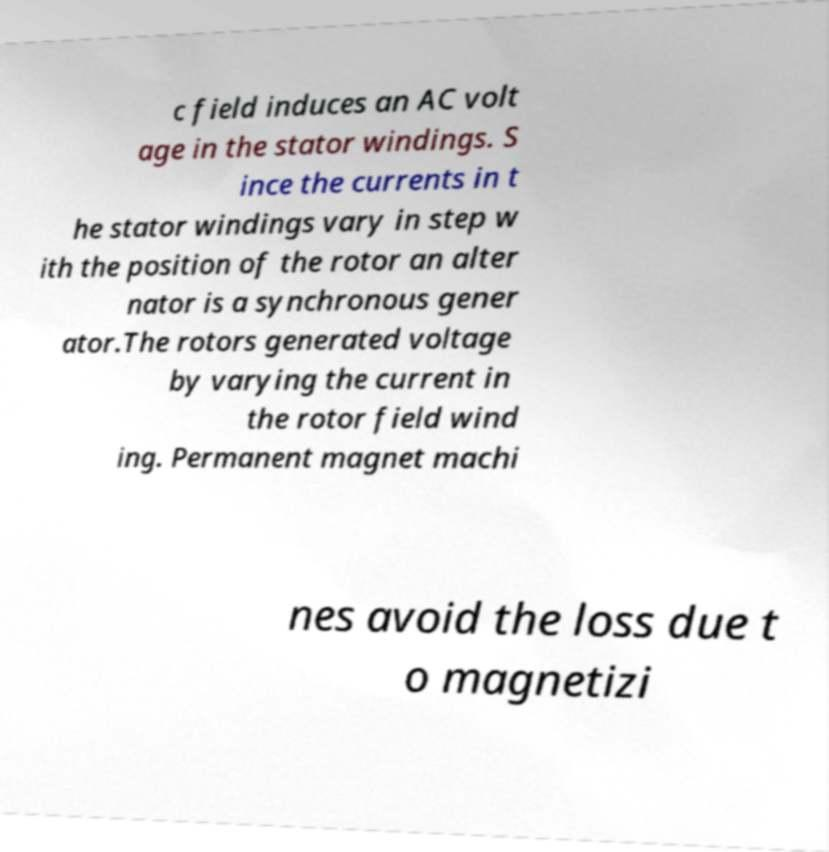Can you read and provide the text displayed in the image?This photo seems to have some interesting text. Can you extract and type it out for me? c field induces an AC volt age in the stator windings. S ince the currents in t he stator windings vary in step w ith the position of the rotor an alter nator is a synchronous gener ator.The rotors generated voltage by varying the current in the rotor field wind ing. Permanent magnet machi nes avoid the loss due t o magnetizi 